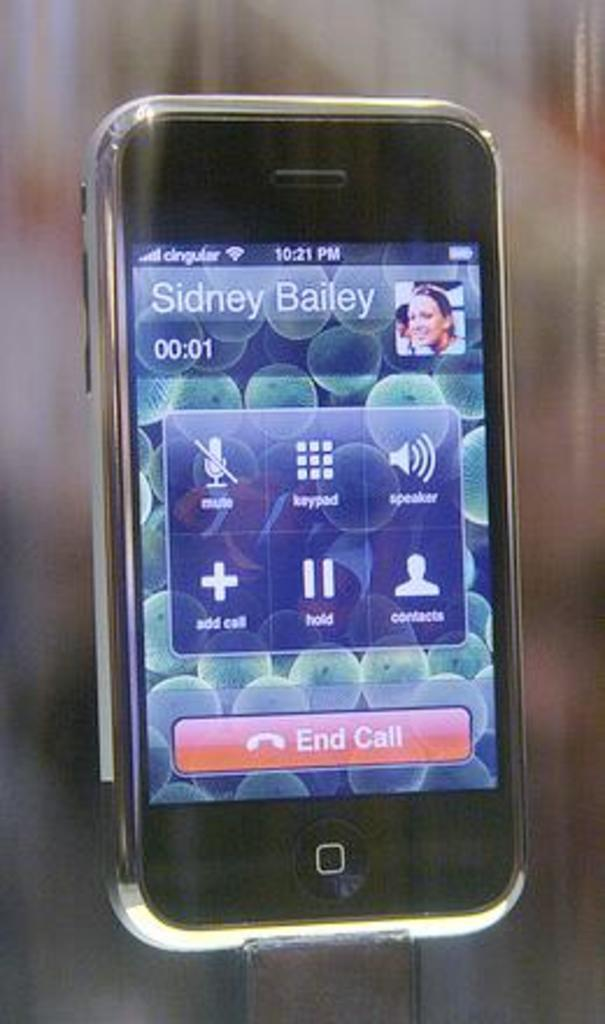Provide a one-sentence caption for the provided image. A cell phone with a picture and Sidney Bailey at the top. 